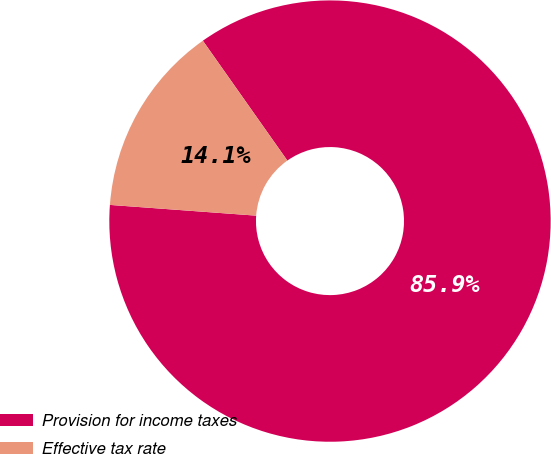Convert chart to OTSL. <chart><loc_0><loc_0><loc_500><loc_500><pie_chart><fcel>Provision for income taxes<fcel>Effective tax rate<nl><fcel>85.94%<fcel>14.06%<nl></chart> 